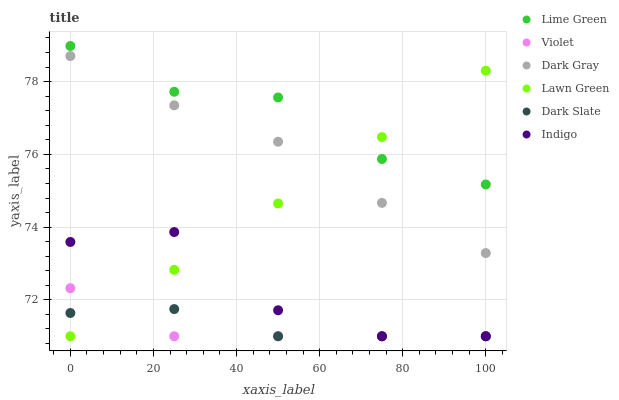Does Violet have the minimum area under the curve?
Answer yes or no. Yes. Does Lime Green have the maximum area under the curve?
Answer yes or no. Yes. Does Indigo have the minimum area under the curve?
Answer yes or no. No. Does Indigo have the maximum area under the curve?
Answer yes or no. No. Is Lawn Green the smoothest?
Answer yes or no. Yes. Is Indigo the roughest?
Answer yes or no. Yes. Is Dark Gray the smoothest?
Answer yes or no. No. Is Dark Gray the roughest?
Answer yes or no. No. Does Lawn Green have the lowest value?
Answer yes or no. Yes. Does Dark Gray have the lowest value?
Answer yes or no. No. Does Lime Green have the highest value?
Answer yes or no. Yes. Does Indigo have the highest value?
Answer yes or no. No. Is Violet less than Dark Gray?
Answer yes or no. Yes. Is Lime Green greater than Dark Slate?
Answer yes or no. Yes. Does Dark Slate intersect Violet?
Answer yes or no. Yes. Is Dark Slate less than Violet?
Answer yes or no. No. Is Dark Slate greater than Violet?
Answer yes or no. No. Does Violet intersect Dark Gray?
Answer yes or no. No. 